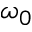Convert formula to latex. <formula><loc_0><loc_0><loc_500><loc_500>\omega _ { 0 }</formula> 